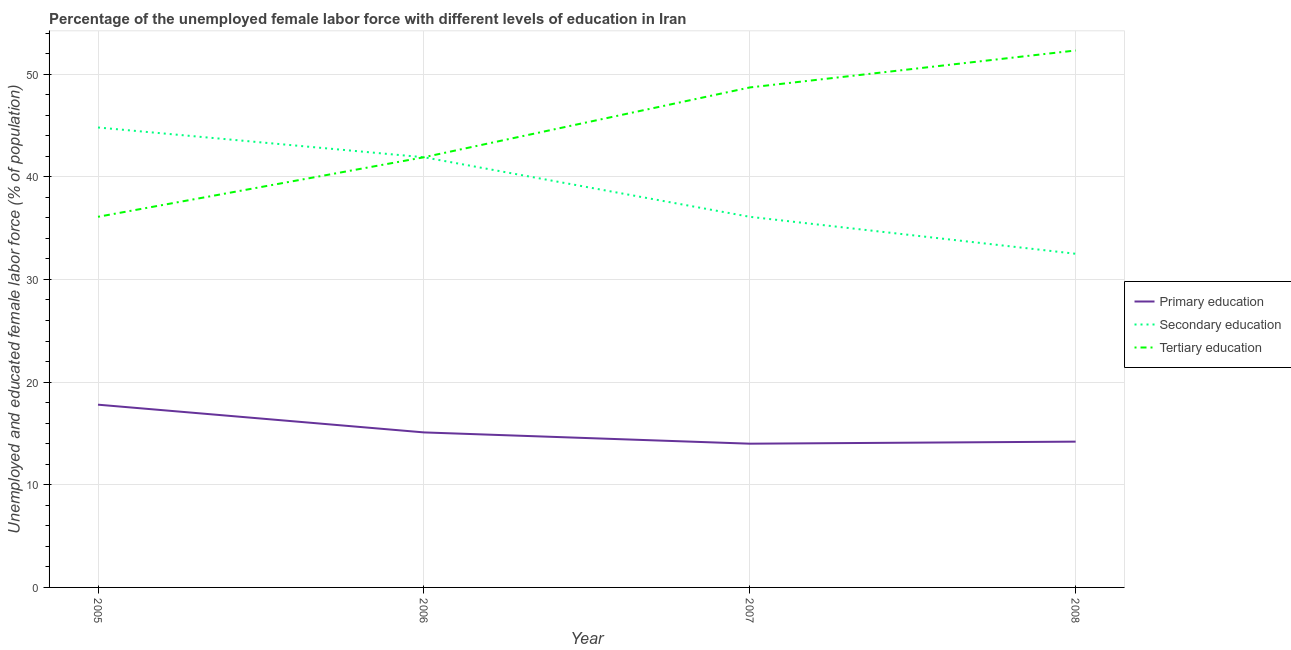How many different coloured lines are there?
Your answer should be compact. 3. Does the line corresponding to percentage of female labor force who received secondary education intersect with the line corresponding to percentage of female labor force who received primary education?
Provide a succinct answer. No. What is the percentage of female labor force who received primary education in 2006?
Give a very brief answer. 15.1. Across all years, what is the maximum percentage of female labor force who received secondary education?
Offer a terse response. 44.8. Across all years, what is the minimum percentage of female labor force who received secondary education?
Provide a succinct answer. 32.5. What is the total percentage of female labor force who received primary education in the graph?
Your response must be concise. 61.1. What is the difference between the percentage of female labor force who received secondary education in 2006 and that in 2008?
Ensure brevity in your answer.  9.4. What is the difference between the percentage of female labor force who received secondary education in 2007 and the percentage of female labor force who received primary education in 2005?
Provide a succinct answer. 18.3. What is the average percentage of female labor force who received tertiary education per year?
Ensure brevity in your answer.  44.75. In the year 2008, what is the difference between the percentage of female labor force who received secondary education and percentage of female labor force who received primary education?
Your response must be concise. 18.3. What is the ratio of the percentage of female labor force who received secondary education in 2005 to that in 2008?
Offer a very short reply. 1.38. What is the difference between the highest and the second highest percentage of female labor force who received primary education?
Provide a short and direct response. 2.7. What is the difference between the highest and the lowest percentage of female labor force who received primary education?
Ensure brevity in your answer.  3.8. In how many years, is the percentage of female labor force who received primary education greater than the average percentage of female labor force who received primary education taken over all years?
Offer a terse response. 1. Is it the case that in every year, the sum of the percentage of female labor force who received primary education and percentage of female labor force who received secondary education is greater than the percentage of female labor force who received tertiary education?
Offer a very short reply. No. Is the percentage of female labor force who received primary education strictly greater than the percentage of female labor force who received tertiary education over the years?
Your answer should be very brief. No. How many lines are there?
Provide a short and direct response. 3. What is the difference between two consecutive major ticks on the Y-axis?
Keep it short and to the point. 10. Does the graph contain grids?
Make the answer very short. Yes. Where does the legend appear in the graph?
Your answer should be very brief. Center right. How many legend labels are there?
Make the answer very short. 3. How are the legend labels stacked?
Your answer should be compact. Vertical. What is the title of the graph?
Ensure brevity in your answer.  Percentage of the unemployed female labor force with different levels of education in Iran. Does "Nuclear sources" appear as one of the legend labels in the graph?
Provide a succinct answer. No. What is the label or title of the Y-axis?
Offer a terse response. Unemployed and educated female labor force (% of population). What is the Unemployed and educated female labor force (% of population) in Primary education in 2005?
Ensure brevity in your answer.  17.8. What is the Unemployed and educated female labor force (% of population) in Secondary education in 2005?
Ensure brevity in your answer.  44.8. What is the Unemployed and educated female labor force (% of population) of Tertiary education in 2005?
Make the answer very short. 36.1. What is the Unemployed and educated female labor force (% of population) in Primary education in 2006?
Offer a terse response. 15.1. What is the Unemployed and educated female labor force (% of population) in Secondary education in 2006?
Ensure brevity in your answer.  41.9. What is the Unemployed and educated female labor force (% of population) of Tertiary education in 2006?
Offer a very short reply. 41.9. What is the Unemployed and educated female labor force (% of population) of Secondary education in 2007?
Your answer should be compact. 36.1. What is the Unemployed and educated female labor force (% of population) in Tertiary education in 2007?
Your answer should be very brief. 48.7. What is the Unemployed and educated female labor force (% of population) in Primary education in 2008?
Your answer should be compact. 14.2. What is the Unemployed and educated female labor force (% of population) in Secondary education in 2008?
Keep it short and to the point. 32.5. What is the Unemployed and educated female labor force (% of population) of Tertiary education in 2008?
Make the answer very short. 52.3. Across all years, what is the maximum Unemployed and educated female labor force (% of population) of Primary education?
Your response must be concise. 17.8. Across all years, what is the maximum Unemployed and educated female labor force (% of population) in Secondary education?
Make the answer very short. 44.8. Across all years, what is the maximum Unemployed and educated female labor force (% of population) in Tertiary education?
Make the answer very short. 52.3. Across all years, what is the minimum Unemployed and educated female labor force (% of population) in Secondary education?
Offer a terse response. 32.5. Across all years, what is the minimum Unemployed and educated female labor force (% of population) in Tertiary education?
Offer a very short reply. 36.1. What is the total Unemployed and educated female labor force (% of population) of Primary education in the graph?
Your answer should be compact. 61.1. What is the total Unemployed and educated female labor force (% of population) of Secondary education in the graph?
Provide a short and direct response. 155.3. What is the total Unemployed and educated female labor force (% of population) in Tertiary education in the graph?
Ensure brevity in your answer.  179. What is the difference between the Unemployed and educated female labor force (% of population) in Secondary education in 2005 and that in 2006?
Your response must be concise. 2.9. What is the difference between the Unemployed and educated female labor force (% of population) in Primary education in 2005 and that in 2007?
Ensure brevity in your answer.  3.8. What is the difference between the Unemployed and educated female labor force (% of population) in Tertiary education in 2005 and that in 2007?
Your response must be concise. -12.6. What is the difference between the Unemployed and educated female labor force (% of population) of Primary education in 2005 and that in 2008?
Ensure brevity in your answer.  3.6. What is the difference between the Unemployed and educated female labor force (% of population) of Tertiary education in 2005 and that in 2008?
Keep it short and to the point. -16.2. What is the difference between the Unemployed and educated female labor force (% of population) of Primary education in 2006 and that in 2007?
Your answer should be very brief. 1.1. What is the difference between the Unemployed and educated female labor force (% of population) of Secondary education in 2006 and that in 2007?
Offer a terse response. 5.8. What is the difference between the Unemployed and educated female labor force (% of population) of Tertiary education in 2006 and that in 2007?
Provide a short and direct response. -6.8. What is the difference between the Unemployed and educated female labor force (% of population) of Primary education in 2006 and that in 2008?
Your answer should be compact. 0.9. What is the difference between the Unemployed and educated female labor force (% of population) of Secondary education in 2006 and that in 2008?
Your response must be concise. 9.4. What is the difference between the Unemployed and educated female labor force (% of population) in Tertiary education in 2006 and that in 2008?
Keep it short and to the point. -10.4. What is the difference between the Unemployed and educated female labor force (% of population) in Primary education in 2007 and that in 2008?
Give a very brief answer. -0.2. What is the difference between the Unemployed and educated female labor force (% of population) in Secondary education in 2007 and that in 2008?
Ensure brevity in your answer.  3.6. What is the difference between the Unemployed and educated female labor force (% of population) in Primary education in 2005 and the Unemployed and educated female labor force (% of population) in Secondary education in 2006?
Provide a short and direct response. -24.1. What is the difference between the Unemployed and educated female labor force (% of population) in Primary education in 2005 and the Unemployed and educated female labor force (% of population) in Tertiary education in 2006?
Your answer should be very brief. -24.1. What is the difference between the Unemployed and educated female labor force (% of population) in Primary education in 2005 and the Unemployed and educated female labor force (% of population) in Secondary education in 2007?
Provide a succinct answer. -18.3. What is the difference between the Unemployed and educated female labor force (% of population) in Primary education in 2005 and the Unemployed and educated female labor force (% of population) in Tertiary education in 2007?
Your response must be concise. -30.9. What is the difference between the Unemployed and educated female labor force (% of population) in Primary education in 2005 and the Unemployed and educated female labor force (% of population) in Secondary education in 2008?
Keep it short and to the point. -14.7. What is the difference between the Unemployed and educated female labor force (% of population) in Primary education in 2005 and the Unemployed and educated female labor force (% of population) in Tertiary education in 2008?
Keep it short and to the point. -34.5. What is the difference between the Unemployed and educated female labor force (% of population) in Secondary education in 2005 and the Unemployed and educated female labor force (% of population) in Tertiary education in 2008?
Make the answer very short. -7.5. What is the difference between the Unemployed and educated female labor force (% of population) of Primary education in 2006 and the Unemployed and educated female labor force (% of population) of Secondary education in 2007?
Provide a short and direct response. -21. What is the difference between the Unemployed and educated female labor force (% of population) of Primary education in 2006 and the Unemployed and educated female labor force (% of population) of Tertiary education in 2007?
Your answer should be compact. -33.6. What is the difference between the Unemployed and educated female labor force (% of population) of Primary education in 2006 and the Unemployed and educated female labor force (% of population) of Secondary education in 2008?
Offer a terse response. -17.4. What is the difference between the Unemployed and educated female labor force (% of population) in Primary education in 2006 and the Unemployed and educated female labor force (% of population) in Tertiary education in 2008?
Your answer should be very brief. -37.2. What is the difference between the Unemployed and educated female labor force (% of population) in Secondary education in 2006 and the Unemployed and educated female labor force (% of population) in Tertiary education in 2008?
Ensure brevity in your answer.  -10.4. What is the difference between the Unemployed and educated female labor force (% of population) of Primary education in 2007 and the Unemployed and educated female labor force (% of population) of Secondary education in 2008?
Your answer should be very brief. -18.5. What is the difference between the Unemployed and educated female labor force (% of population) of Primary education in 2007 and the Unemployed and educated female labor force (% of population) of Tertiary education in 2008?
Provide a succinct answer. -38.3. What is the difference between the Unemployed and educated female labor force (% of population) in Secondary education in 2007 and the Unemployed and educated female labor force (% of population) in Tertiary education in 2008?
Provide a succinct answer. -16.2. What is the average Unemployed and educated female labor force (% of population) of Primary education per year?
Ensure brevity in your answer.  15.28. What is the average Unemployed and educated female labor force (% of population) in Secondary education per year?
Offer a terse response. 38.83. What is the average Unemployed and educated female labor force (% of population) of Tertiary education per year?
Give a very brief answer. 44.75. In the year 2005, what is the difference between the Unemployed and educated female labor force (% of population) in Primary education and Unemployed and educated female labor force (% of population) in Secondary education?
Offer a terse response. -27. In the year 2005, what is the difference between the Unemployed and educated female labor force (% of population) in Primary education and Unemployed and educated female labor force (% of population) in Tertiary education?
Ensure brevity in your answer.  -18.3. In the year 2005, what is the difference between the Unemployed and educated female labor force (% of population) of Secondary education and Unemployed and educated female labor force (% of population) of Tertiary education?
Your response must be concise. 8.7. In the year 2006, what is the difference between the Unemployed and educated female labor force (% of population) in Primary education and Unemployed and educated female labor force (% of population) in Secondary education?
Keep it short and to the point. -26.8. In the year 2006, what is the difference between the Unemployed and educated female labor force (% of population) in Primary education and Unemployed and educated female labor force (% of population) in Tertiary education?
Make the answer very short. -26.8. In the year 2007, what is the difference between the Unemployed and educated female labor force (% of population) in Primary education and Unemployed and educated female labor force (% of population) in Secondary education?
Your response must be concise. -22.1. In the year 2007, what is the difference between the Unemployed and educated female labor force (% of population) in Primary education and Unemployed and educated female labor force (% of population) in Tertiary education?
Make the answer very short. -34.7. In the year 2007, what is the difference between the Unemployed and educated female labor force (% of population) of Secondary education and Unemployed and educated female labor force (% of population) of Tertiary education?
Your answer should be compact. -12.6. In the year 2008, what is the difference between the Unemployed and educated female labor force (% of population) of Primary education and Unemployed and educated female labor force (% of population) of Secondary education?
Your answer should be very brief. -18.3. In the year 2008, what is the difference between the Unemployed and educated female labor force (% of population) in Primary education and Unemployed and educated female labor force (% of population) in Tertiary education?
Your response must be concise. -38.1. In the year 2008, what is the difference between the Unemployed and educated female labor force (% of population) in Secondary education and Unemployed and educated female labor force (% of population) in Tertiary education?
Make the answer very short. -19.8. What is the ratio of the Unemployed and educated female labor force (% of population) in Primary education in 2005 to that in 2006?
Your answer should be compact. 1.18. What is the ratio of the Unemployed and educated female labor force (% of population) of Secondary education in 2005 to that in 2006?
Provide a succinct answer. 1.07. What is the ratio of the Unemployed and educated female labor force (% of population) of Tertiary education in 2005 to that in 2006?
Offer a very short reply. 0.86. What is the ratio of the Unemployed and educated female labor force (% of population) in Primary education in 2005 to that in 2007?
Offer a very short reply. 1.27. What is the ratio of the Unemployed and educated female labor force (% of population) in Secondary education in 2005 to that in 2007?
Offer a terse response. 1.24. What is the ratio of the Unemployed and educated female labor force (% of population) of Tertiary education in 2005 to that in 2007?
Offer a very short reply. 0.74. What is the ratio of the Unemployed and educated female labor force (% of population) of Primary education in 2005 to that in 2008?
Keep it short and to the point. 1.25. What is the ratio of the Unemployed and educated female labor force (% of population) of Secondary education in 2005 to that in 2008?
Offer a terse response. 1.38. What is the ratio of the Unemployed and educated female labor force (% of population) in Tertiary education in 2005 to that in 2008?
Your answer should be very brief. 0.69. What is the ratio of the Unemployed and educated female labor force (% of population) in Primary education in 2006 to that in 2007?
Provide a succinct answer. 1.08. What is the ratio of the Unemployed and educated female labor force (% of population) of Secondary education in 2006 to that in 2007?
Your response must be concise. 1.16. What is the ratio of the Unemployed and educated female labor force (% of population) in Tertiary education in 2006 to that in 2007?
Provide a short and direct response. 0.86. What is the ratio of the Unemployed and educated female labor force (% of population) in Primary education in 2006 to that in 2008?
Offer a terse response. 1.06. What is the ratio of the Unemployed and educated female labor force (% of population) of Secondary education in 2006 to that in 2008?
Provide a short and direct response. 1.29. What is the ratio of the Unemployed and educated female labor force (% of population) in Tertiary education in 2006 to that in 2008?
Your response must be concise. 0.8. What is the ratio of the Unemployed and educated female labor force (% of population) in Primary education in 2007 to that in 2008?
Your answer should be very brief. 0.99. What is the ratio of the Unemployed and educated female labor force (% of population) of Secondary education in 2007 to that in 2008?
Give a very brief answer. 1.11. What is the ratio of the Unemployed and educated female labor force (% of population) of Tertiary education in 2007 to that in 2008?
Offer a terse response. 0.93. What is the difference between the highest and the second highest Unemployed and educated female labor force (% of population) in Primary education?
Ensure brevity in your answer.  2.7. What is the difference between the highest and the lowest Unemployed and educated female labor force (% of population) in Secondary education?
Offer a terse response. 12.3. What is the difference between the highest and the lowest Unemployed and educated female labor force (% of population) in Tertiary education?
Give a very brief answer. 16.2. 